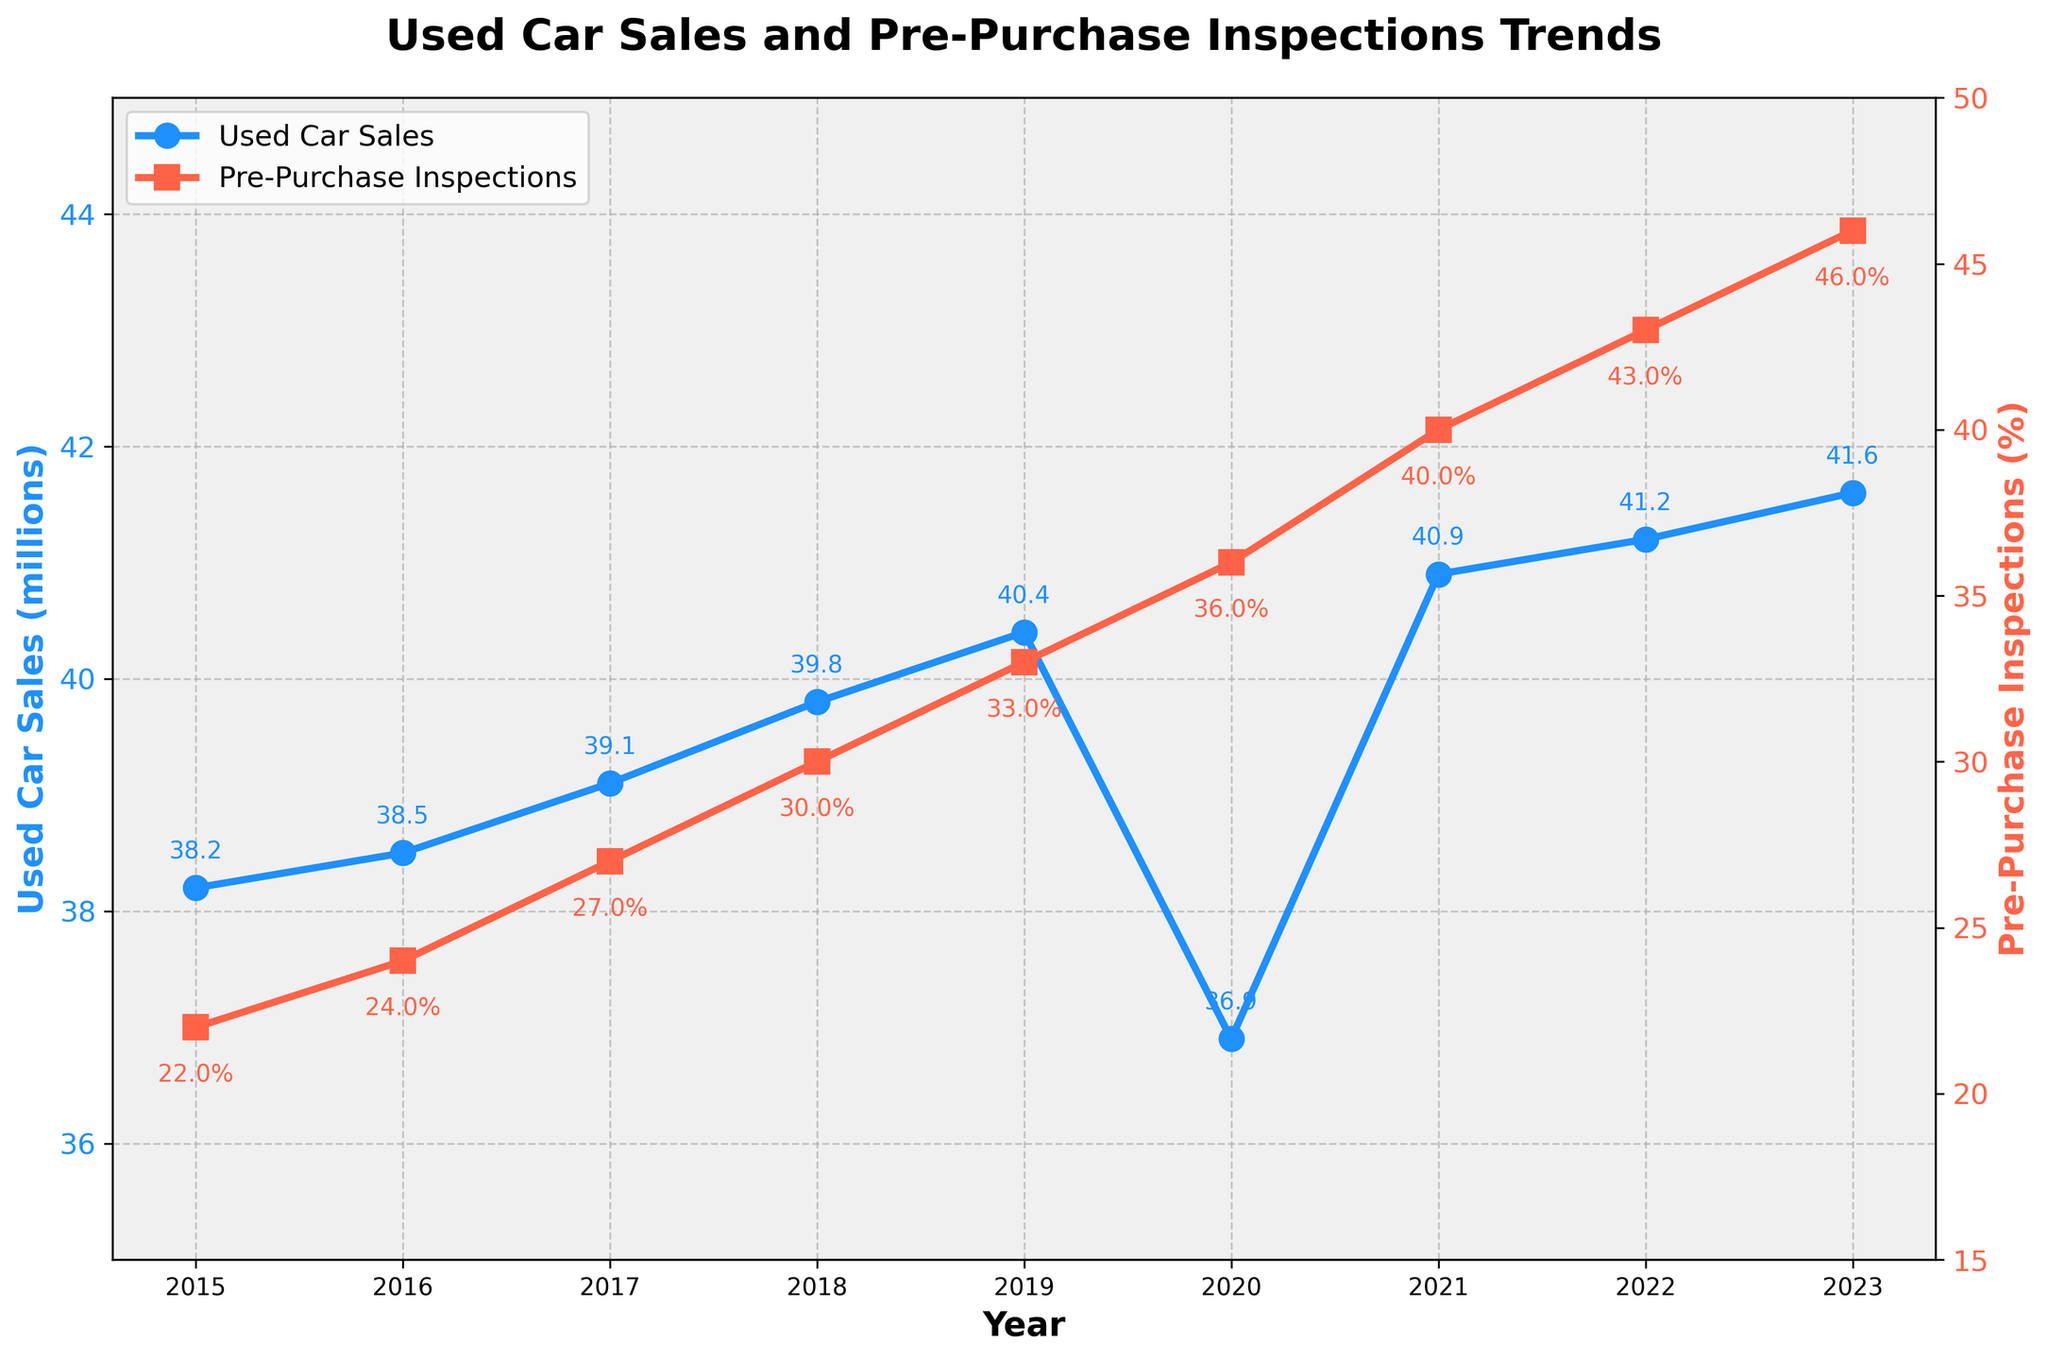When did the percentage of pre-purchase inspections first reach or surpass 30%? The figure shows the percentage of pre-purchase inspections increasing over the years. In 2018, the percentage was first recorded at 30%.
Answer: 2018 How many millions of used car sales were there in the year with the highest percentage of pre-purchase inspections? By inspecting the plot, the highest pre-purchase inspection percentage is in 2023 at 46%. The corresponding used car sales for that year are 41.6 million.
Answer: 41.6 Between which two consecutive years did the percentage of pre-purchase inspections see the greatest increase? Reviewing the changes year over year, the largest increase in the percentage of pre-purchase inspections occurred between 2021 (40%) and 2022 (43%), which is a 3% increase.
Answer: 2021 and 2022 Was there any year when used car sales decreased from the previous year? If so, which year? The figure indicates a dip in used car sales from 2019 (40.4 million) to 2020 (36.9 million).
Answer: 2020 What is the overall trend in used car sales and pre-purchase inspections from 2015 to 2023? Both used car sales and pre-purchase inspections show an overall upward trend from 2015 to 2023, although there is a dip in used car sales in 2020. Pre-purchase inspections steadily increase with no dips.
Answer: Upward trend What was the approximate difference in the percentage of pre-purchase inspections between 2015 and 2023? The percentage of pre-purchase inspections in 2015 was 22%, and it increased to 46% in 2023. The difference is 46% - 22% = 24%.
Answer: 24% In which year did used car sales first exceed 40 million? By looking at the plot, used car sales first exceeded 40 million in 2019, with a value of 40.4 million.
Answer: 2019 Compare the pre-purchase inspection percentages for the years when used car sales were below 40 million. Used car sales were below 40 million in 2015, 2016, 2017, 2018, and 2020. The corresponding pre-purchase inspection percentages for those years are 22%, 24%, 27%, 30%, and 36% respectively.
Answer: 22%, 24%, 27%, 30%, and 36% 